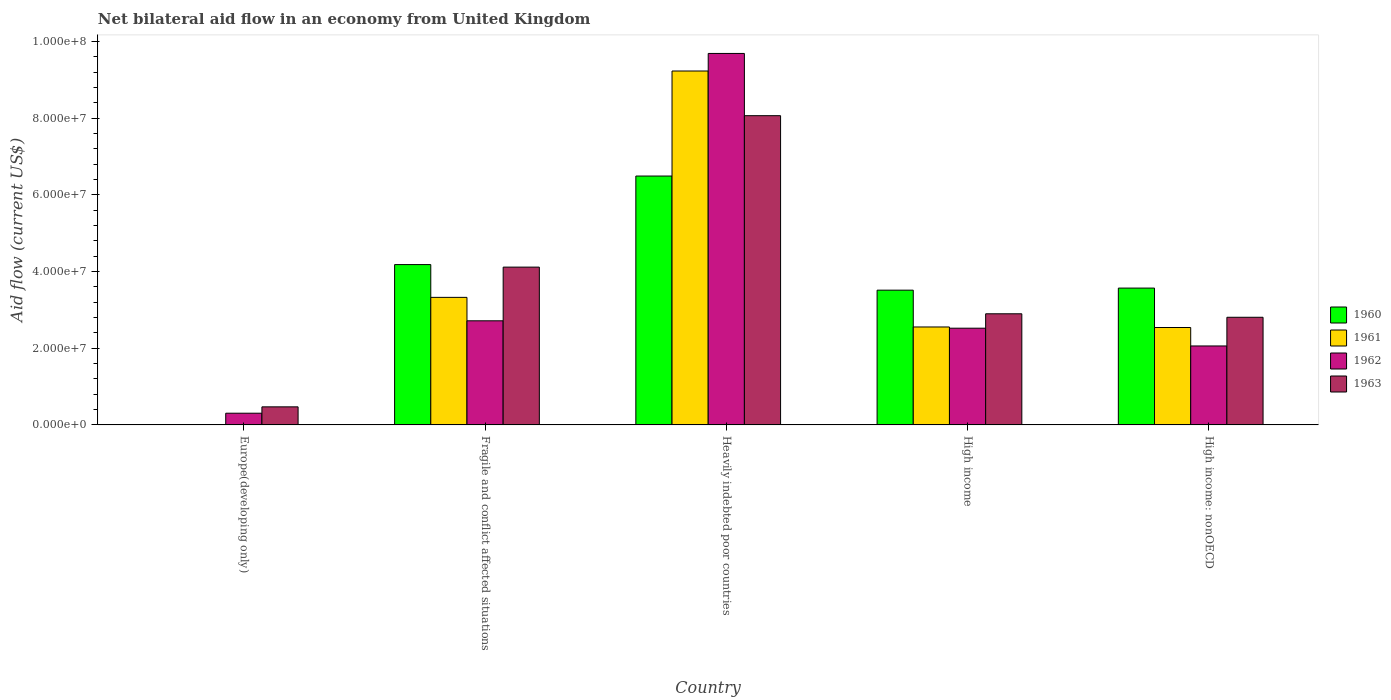How many different coloured bars are there?
Your response must be concise. 4. Are the number of bars per tick equal to the number of legend labels?
Provide a short and direct response. No. How many bars are there on the 1st tick from the left?
Give a very brief answer. 2. In how many cases, is the number of bars for a given country not equal to the number of legend labels?
Provide a succinct answer. 1. What is the net bilateral aid flow in 1960 in Heavily indebted poor countries?
Give a very brief answer. 6.49e+07. Across all countries, what is the maximum net bilateral aid flow in 1960?
Offer a terse response. 6.49e+07. Across all countries, what is the minimum net bilateral aid flow in 1961?
Provide a succinct answer. 0. In which country was the net bilateral aid flow in 1961 maximum?
Ensure brevity in your answer.  Heavily indebted poor countries. What is the total net bilateral aid flow in 1960 in the graph?
Offer a terse response. 1.78e+08. What is the difference between the net bilateral aid flow in 1962 in Europe(developing only) and that in Fragile and conflict affected situations?
Your answer should be compact. -2.41e+07. What is the difference between the net bilateral aid flow in 1963 in Heavily indebted poor countries and the net bilateral aid flow in 1960 in Fragile and conflict affected situations?
Provide a succinct answer. 3.88e+07. What is the average net bilateral aid flow in 1962 per country?
Provide a succinct answer. 3.46e+07. What is the difference between the net bilateral aid flow of/in 1962 and net bilateral aid flow of/in 1963 in Heavily indebted poor countries?
Offer a terse response. 1.62e+07. In how many countries, is the net bilateral aid flow in 1961 greater than 88000000 US$?
Provide a short and direct response. 1. What is the ratio of the net bilateral aid flow in 1961 in Fragile and conflict affected situations to that in Heavily indebted poor countries?
Your response must be concise. 0.36. Is the difference between the net bilateral aid flow in 1962 in Fragile and conflict affected situations and Heavily indebted poor countries greater than the difference between the net bilateral aid flow in 1963 in Fragile and conflict affected situations and Heavily indebted poor countries?
Your answer should be very brief. No. What is the difference between the highest and the second highest net bilateral aid flow in 1960?
Provide a succinct answer. 2.92e+07. What is the difference between the highest and the lowest net bilateral aid flow in 1960?
Make the answer very short. 6.49e+07. In how many countries, is the net bilateral aid flow in 1963 greater than the average net bilateral aid flow in 1963 taken over all countries?
Make the answer very short. 2. Is the sum of the net bilateral aid flow in 1960 in Fragile and conflict affected situations and High income: nonOECD greater than the maximum net bilateral aid flow in 1963 across all countries?
Your response must be concise. No. Is it the case that in every country, the sum of the net bilateral aid flow in 1962 and net bilateral aid flow in 1961 is greater than the sum of net bilateral aid flow in 1960 and net bilateral aid flow in 1963?
Your response must be concise. No. Does the graph contain any zero values?
Your answer should be compact. Yes. Does the graph contain grids?
Offer a terse response. No. How are the legend labels stacked?
Your response must be concise. Vertical. What is the title of the graph?
Keep it short and to the point. Net bilateral aid flow in an economy from United Kingdom. Does "1961" appear as one of the legend labels in the graph?
Ensure brevity in your answer.  Yes. What is the label or title of the X-axis?
Give a very brief answer. Country. What is the Aid flow (current US$) in 1960 in Europe(developing only)?
Your response must be concise. 0. What is the Aid flow (current US$) of 1961 in Europe(developing only)?
Your answer should be compact. 0. What is the Aid flow (current US$) of 1962 in Europe(developing only)?
Ensure brevity in your answer.  3.05e+06. What is the Aid flow (current US$) of 1963 in Europe(developing only)?
Your answer should be very brief. 4.71e+06. What is the Aid flow (current US$) of 1960 in Fragile and conflict affected situations?
Provide a short and direct response. 4.18e+07. What is the Aid flow (current US$) in 1961 in Fragile and conflict affected situations?
Ensure brevity in your answer.  3.33e+07. What is the Aid flow (current US$) in 1962 in Fragile and conflict affected situations?
Offer a very short reply. 2.72e+07. What is the Aid flow (current US$) of 1963 in Fragile and conflict affected situations?
Ensure brevity in your answer.  4.12e+07. What is the Aid flow (current US$) of 1960 in Heavily indebted poor countries?
Your response must be concise. 6.49e+07. What is the Aid flow (current US$) of 1961 in Heavily indebted poor countries?
Keep it short and to the point. 9.23e+07. What is the Aid flow (current US$) of 1962 in Heavily indebted poor countries?
Your answer should be compact. 9.69e+07. What is the Aid flow (current US$) of 1963 in Heavily indebted poor countries?
Your answer should be compact. 8.06e+07. What is the Aid flow (current US$) in 1960 in High income?
Offer a terse response. 3.51e+07. What is the Aid flow (current US$) in 1961 in High income?
Give a very brief answer. 2.55e+07. What is the Aid flow (current US$) in 1962 in High income?
Provide a short and direct response. 2.52e+07. What is the Aid flow (current US$) of 1963 in High income?
Keep it short and to the point. 2.90e+07. What is the Aid flow (current US$) in 1960 in High income: nonOECD?
Give a very brief answer. 3.57e+07. What is the Aid flow (current US$) of 1961 in High income: nonOECD?
Give a very brief answer. 2.54e+07. What is the Aid flow (current US$) in 1962 in High income: nonOECD?
Make the answer very short. 2.06e+07. What is the Aid flow (current US$) of 1963 in High income: nonOECD?
Ensure brevity in your answer.  2.81e+07. Across all countries, what is the maximum Aid flow (current US$) of 1960?
Ensure brevity in your answer.  6.49e+07. Across all countries, what is the maximum Aid flow (current US$) in 1961?
Make the answer very short. 9.23e+07. Across all countries, what is the maximum Aid flow (current US$) of 1962?
Give a very brief answer. 9.69e+07. Across all countries, what is the maximum Aid flow (current US$) of 1963?
Give a very brief answer. 8.06e+07. Across all countries, what is the minimum Aid flow (current US$) in 1962?
Provide a short and direct response. 3.05e+06. Across all countries, what is the minimum Aid flow (current US$) of 1963?
Offer a very short reply. 4.71e+06. What is the total Aid flow (current US$) of 1960 in the graph?
Provide a succinct answer. 1.78e+08. What is the total Aid flow (current US$) in 1961 in the graph?
Your response must be concise. 1.76e+08. What is the total Aid flow (current US$) of 1962 in the graph?
Ensure brevity in your answer.  1.73e+08. What is the total Aid flow (current US$) of 1963 in the graph?
Offer a terse response. 1.84e+08. What is the difference between the Aid flow (current US$) of 1962 in Europe(developing only) and that in Fragile and conflict affected situations?
Your answer should be compact. -2.41e+07. What is the difference between the Aid flow (current US$) in 1963 in Europe(developing only) and that in Fragile and conflict affected situations?
Offer a very short reply. -3.64e+07. What is the difference between the Aid flow (current US$) of 1962 in Europe(developing only) and that in Heavily indebted poor countries?
Offer a terse response. -9.38e+07. What is the difference between the Aid flow (current US$) of 1963 in Europe(developing only) and that in Heavily indebted poor countries?
Provide a short and direct response. -7.59e+07. What is the difference between the Aid flow (current US$) in 1962 in Europe(developing only) and that in High income?
Make the answer very short. -2.22e+07. What is the difference between the Aid flow (current US$) in 1963 in Europe(developing only) and that in High income?
Offer a terse response. -2.43e+07. What is the difference between the Aid flow (current US$) in 1962 in Europe(developing only) and that in High income: nonOECD?
Your answer should be compact. -1.75e+07. What is the difference between the Aid flow (current US$) of 1963 in Europe(developing only) and that in High income: nonOECD?
Keep it short and to the point. -2.34e+07. What is the difference between the Aid flow (current US$) of 1960 in Fragile and conflict affected situations and that in Heavily indebted poor countries?
Keep it short and to the point. -2.31e+07. What is the difference between the Aid flow (current US$) of 1961 in Fragile and conflict affected situations and that in Heavily indebted poor countries?
Provide a succinct answer. -5.90e+07. What is the difference between the Aid flow (current US$) of 1962 in Fragile and conflict affected situations and that in Heavily indebted poor countries?
Offer a terse response. -6.97e+07. What is the difference between the Aid flow (current US$) in 1963 in Fragile and conflict affected situations and that in Heavily indebted poor countries?
Your response must be concise. -3.95e+07. What is the difference between the Aid flow (current US$) in 1960 in Fragile and conflict affected situations and that in High income?
Give a very brief answer. 6.67e+06. What is the difference between the Aid flow (current US$) in 1961 in Fragile and conflict affected situations and that in High income?
Make the answer very short. 7.72e+06. What is the difference between the Aid flow (current US$) of 1962 in Fragile and conflict affected situations and that in High income?
Give a very brief answer. 1.93e+06. What is the difference between the Aid flow (current US$) of 1963 in Fragile and conflict affected situations and that in High income?
Provide a succinct answer. 1.22e+07. What is the difference between the Aid flow (current US$) in 1960 in Fragile and conflict affected situations and that in High income: nonOECD?
Ensure brevity in your answer.  6.13e+06. What is the difference between the Aid flow (current US$) in 1961 in Fragile and conflict affected situations and that in High income: nonOECD?
Keep it short and to the point. 7.86e+06. What is the difference between the Aid flow (current US$) in 1962 in Fragile and conflict affected situations and that in High income: nonOECD?
Make the answer very short. 6.56e+06. What is the difference between the Aid flow (current US$) of 1963 in Fragile and conflict affected situations and that in High income: nonOECD?
Your response must be concise. 1.31e+07. What is the difference between the Aid flow (current US$) in 1960 in Heavily indebted poor countries and that in High income?
Ensure brevity in your answer.  2.98e+07. What is the difference between the Aid flow (current US$) of 1961 in Heavily indebted poor countries and that in High income?
Keep it short and to the point. 6.68e+07. What is the difference between the Aid flow (current US$) of 1962 in Heavily indebted poor countries and that in High income?
Ensure brevity in your answer.  7.16e+07. What is the difference between the Aid flow (current US$) of 1963 in Heavily indebted poor countries and that in High income?
Your answer should be very brief. 5.17e+07. What is the difference between the Aid flow (current US$) in 1960 in Heavily indebted poor countries and that in High income: nonOECD?
Make the answer very short. 2.92e+07. What is the difference between the Aid flow (current US$) of 1961 in Heavily indebted poor countries and that in High income: nonOECD?
Provide a succinct answer. 6.69e+07. What is the difference between the Aid flow (current US$) in 1962 in Heavily indebted poor countries and that in High income: nonOECD?
Give a very brief answer. 7.63e+07. What is the difference between the Aid flow (current US$) in 1963 in Heavily indebted poor countries and that in High income: nonOECD?
Your response must be concise. 5.26e+07. What is the difference between the Aid flow (current US$) of 1960 in High income and that in High income: nonOECD?
Your answer should be very brief. -5.40e+05. What is the difference between the Aid flow (current US$) of 1961 in High income and that in High income: nonOECD?
Offer a terse response. 1.40e+05. What is the difference between the Aid flow (current US$) in 1962 in High income and that in High income: nonOECD?
Your response must be concise. 4.63e+06. What is the difference between the Aid flow (current US$) of 1963 in High income and that in High income: nonOECD?
Keep it short and to the point. 9.10e+05. What is the difference between the Aid flow (current US$) of 1962 in Europe(developing only) and the Aid flow (current US$) of 1963 in Fragile and conflict affected situations?
Give a very brief answer. -3.81e+07. What is the difference between the Aid flow (current US$) in 1962 in Europe(developing only) and the Aid flow (current US$) in 1963 in Heavily indebted poor countries?
Your answer should be compact. -7.76e+07. What is the difference between the Aid flow (current US$) in 1962 in Europe(developing only) and the Aid flow (current US$) in 1963 in High income?
Provide a short and direct response. -2.59e+07. What is the difference between the Aid flow (current US$) in 1962 in Europe(developing only) and the Aid flow (current US$) in 1963 in High income: nonOECD?
Your answer should be compact. -2.50e+07. What is the difference between the Aid flow (current US$) in 1960 in Fragile and conflict affected situations and the Aid flow (current US$) in 1961 in Heavily indebted poor countries?
Your answer should be very brief. -5.05e+07. What is the difference between the Aid flow (current US$) of 1960 in Fragile and conflict affected situations and the Aid flow (current US$) of 1962 in Heavily indebted poor countries?
Offer a very short reply. -5.51e+07. What is the difference between the Aid flow (current US$) of 1960 in Fragile and conflict affected situations and the Aid flow (current US$) of 1963 in Heavily indebted poor countries?
Offer a very short reply. -3.88e+07. What is the difference between the Aid flow (current US$) of 1961 in Fragile and conflict affected situations and the Aid flow (current US$) of 1962 in Heavily indebted poor countries?
Offer a terse response. -6.36e+07. What is the difference between the Aid flow (current US$) of 1961 in Fragile and conflict affected situations and the Aid flow (current US$) of 1963 in Heavily indebted poor countries?
Make the answer very short. -4.74e+07. What is the difference between the Aid flow (current US$) of 1962 in Fragile and conflict affected situations and the Aid flow (current US$) of 1963 in Heavily indebted poor countries?
Your response must be concise. -5.35e+07. What is the difference between the Aid flow (current US$) in 1960 in Fragile and conflict affected situations and the Aid flow (current US$) in 1961 in High income?
Offer a very short reply. 1.63e+07. What is the difference between the Aid flow (current US$) of 1960 in Fragile and conflict affected situations and the Aid flow (current US$) of 1962 in High income?
Offer a terse response. 1.66e+07. What is the difference between the Aid flow (current US$) in 1960 in Fragile and conflict affected situations and the Aid flow (current US$) in 1963 in High income?
Your answer should be very brief. 1.28e+07. What is the difference between the Aid flow (current US$) in 1961 in Fragile and conflict affected situations and the Aid flow (current US$) in 1962 in High income?
Provide a short and direct response. 8.04e+06. What is the difference between the Aid flow (current US$) of 1961 in Fragile and conflict affected situations and the Aid flow (current US$) of 1963 in High income?
Keep it short and to the point. 4.28e+06. What is the difference between the Aid flow (current US$) in 1962 in Fragile and conflict affected situations and the Aid flow (current US$) in 1963 in High income?
Ensure brevity in your answer.  -1.83e+06. What is the difference between the Aid flow (current US$) of 1960 in Fragile and conflict affected situations and the Aid flow (current US$) of 1961 in High income: nonOECD?
Keep it short and to the point. 1.64e+07. What is the difference between the Aid flow (current US$) in 1960 in Fragile and conflict affected situations and the Aid flow (current US$) in 1962 in High income: nonOECD?
Keep it short and to the point. 2.12e+07. What is the difference between the Aid flow (current US$) of 1960 in Fragile and conflict affected situations and the Aid flow (current US$) of 1963 in High income: nonOECD?
Your response must be concise. 1.37e+07. What is the difference between the Aid flow (current US$) in 1961 in Fragile and conflict affected situations and the Aid flow (current US$) in 1962 in High income: nonOECD?
Provide a short and direct response. 1.27e+07. What is the difference between the Aid flow (current US$) in 1961 in Fragile and conflict affected situations and the Aid flow (current US$) in 1963 in High income: nonOECD?
Give a very brief answer. 5.19e+06. What is the difference between the Aid flow (current US$) of 1962 in Fragile and conflict affected situations and the Aid flow (current US$) of 1963 in High income: nonOECD?
Your answer should be compact. -9.20e+05. What is the difference between the Aid flow (current US$) in 1960 in Heavily indebted poor countries and the Aid flow (current US$) in 1961 in High income?
Make the answer very short. 3.94e+07. What is the difference between the Aid flow (current US$) of 1960 in Heavily indebted poor countries and the Aid flow (current US$) of 1962 in High income?
Give a very brief answer. 3.97e+07. What is the difference between the Aid flow (current US$) of 1960 in Heavily indebted poor countries and the Aid flow (current US$) of 1963 in High income?
Make the answer very short. 3.59e+07. What is the difference between the Aid flow (current US$) in 1961 in Heavily indebted poor countries and the Aid flow (current US$) in 1962 in High income?
Ensure brevity in your answer.  6.71e+07. What is the difference between the Aid flow (current US$) in 1961 in Heavily indebted poor countries and the Aid flow (current US$) in 1963 in High income?
Make the answer very short. 6.33e+07. What is the difference between the Aid flow (current US$) of 1962 in Heavily indebted poor countries and the Aid flow (current US$) of 1963 in High income?
Provide a short and direct response. 6.79e+07. What is the difference between the Aid flow (current US$) of 1960 in Heavily indebted poor countries and the Aid flow (current US$) of 1961 in High income: nonOECD?
Ensure brevity in your answer.  3.95e+07. What is the difference between the Aid flow (current US$) of 1960 in Heavily indebted poor countries and the Aid flow (current US$) of 1962 in High income: nonOECD?
Offer a very short reply. 4.43e+07. What is the difference between the Aid flow (current US$) of 1960 in Heavily indebted poor countries and the Aid flow (current US$) of 1963 in High income: nonOECD?
Make the answer very short. 3.68e+07. What is the difference between the Aid flow (current US$) of 1961 in Heavily indebted poor countries and the Aid flow (current US$) of 1962 in High income: nonOECD?
Your answer should be compact. 7.17e+07. What is the difference between the Aid flow (current US$) in 1961 in Heavily indebted poor countries and the Aid flow (current US$) in 1963 in High income: nonOECD?
Your answer should be compact. 6.42e+07. What is the difference between the Aid flow (current US$) in 1962 in Heavily indebted poor countries and the Aid flow (current US$) in 1963 in High income: nonOECD?
Your answer should be very brief. 6.88e+07. What is the difference between the Aid flow (current US$) of 1960 in High income and the Aid flow (current US$) of 1961 in High income: nonOECD?
Keep it short and to the point. 9.74e+06. What is the difference between the Aid flow (current US$) in 1960 in High income and the Aid flow (current US$) in 1962 in High income: nonOECD?
Your answer should be compact. 1.46e+07. What is the difference between the Aid flow (current US$) in 1960 in High income and the Aid flow (current US$) in 1963 in High income: nonOECD?
Your answer should be very brief. 7.07e+06. What is the difference between the Aid flow (current US$) of 1961 in High income and the Aid flow (current US$) of 1962 in High income: nonOECD?
Give a very brief answer. 4.95e+06. What is the difference between the Aid flow (current US$) in 1961 in High income and the Aid flow (current US$) in 1963 in High income: nonOECD?
Offer a very short reply. -2.53e+06. What is the difference between the Aid flow (current US$) in 1962 in High income and the Aid flow (current US$) in 1963 in High income: nonOECD?
Give a very brief answer. -2.85e+06. What is the average Aid flow (current US$) in 1960 per country?
Ensure brevity in your answer.  3.55e+07. What is the average Aid flow (current US$) of 1961 per country?
Offer a terse response. 3.53e+07. What is the average Aid flow (current US$) in 1962 per country?
Your response must be concise. 3.46e+07. What is the average Aid flow (current US$) in 1963 per country?
Your response must be concise. 3.67e+07. What is the difference between the Aid flow (current US$) of 1962 and Aid flow (current US$) of 1963 in Europe(developing only)?
Ensure brevity in your answer.  -1.66e+06. What is the difference between the Aid flow (current US$) of 1960 and Aid flow (current US$) of 1961 in Fragile and conflict affected situations?
Keep it short and to the point. 8.55e+06. What is the difference between the Aid flow (current US$) of 1960 and Aid flow (current US$) of 1962 in Fragile and conflict affected situations?
Your response must be concise. 1.47e+07. What is the difference between the Aid flow (current US$) in 1960 and Aid flow (current US$) in 1963 in Fragile and conflict affected situations?
Offer a terse response. 6.60e+05. What is the difference between the Aid flow (current US$) in 1961 and Aid flow (current US$) in 1962 in Fragile and conflict affected situations?
Ensure brevity in your answer.  6.11e+06. What is the difference between the Aid flow (current US$) in 1961 and Aid flow (current US$) in 1963 in Fragile and conflict affected situations?
Your answer should be very brief. -7.89e+06. What is the difference between the Aid flow (current US$) of 1962 and Aid flow (current US$) of 1963 in Fragile and conflict affected situations?
Provide a succinct answer. -1.40e+07. What is the difference between the Aid flow (current US$) in 1960 and Aid flow (current US$) in 1961 in Heavily indebted poor countries?
Your answer should be compact. -2.74e+07. What is the difference between the Aid flow (current US$) of 1960 and Aid flow (current US$) of 1962 in Heavily indebted poor countries?
Your answer should be compact. -3.20e+07. What is the difference between the Aid flow (current US$) of 1960 and Aid flow (current US$) of 1963 in Heavily indebted poor countries?
Give a very brief answer. -1.57e+07. What is the difference between the Aid flow (current US$) of 1961 and Aid flow (current US$) of 1962 in Heavily indebted poor countries?
Offer a very short reply. -4.58e+06. What is the difference between the Aid flow (current US$) in 1961 and Aid flow (current US$) in 1963 in Heavily indebted poor countries?
Your response must be concise. 1.16e+07. What is the difference between the Aid flow (current US$) of 1962 and Aid flow (current US$) of 1963 in Heavily indebted poor countries?
Offer a terse response. 1.62e+07. What is the difference between the Aid flow (current US$) in 1960 and Aid flow (current US$) in 1961 in High income?
Give a very brief answer. 9.60e+06. What is the difference between the Aid flow (current US$) of 1960 and Aid flow (current US$) of 1962 in High income?
Your response must be concise. 9.92e+06. What is the difference between the Aid flow (current US$) in 1960 and Aid flow (current US$) in 1963 in High income?
Provide a succinct answer. 6.16e+06. What is the difference between the Aid flow (current US$) of 1961 and Aid flow (current US$) of 1963 in High income?
Give a very brief answer. -3.44e+06. What is the difference between the Aid flow (current US$) of 1962 and Aid flow (current US$) of 1963 in High income?
Make the answer very short. -3.76e+06. What is the difference between the Aid flow (current US$) in 1960 and Aid flow (current US$) in 1961 in High income: nonOECD?
Ensure brevity in your answer.  1.03e+07. What is the difference between the Aid flow (current US$) in 1960 and Aid flow (current US$) in 1962 in High income: nonOECD?
Ensure brevity in your answer.  1.51e+07. What is the difference between the Aid flow (current US$) in 1960 and Aid flow (current US$) in 1963 in High income: nonOECD?
Give a very brief answer. 7.61e+06. What is the difference between the Aid flow (current US$) of 1961 and Aid flow (current US$) of 1962 in High income: nonOECD?
Offer a very short reply. 4.81e+06. What is the difference between the Aid flow (current US$) in 1961 and Aid flow (current US$) in 1963 in High income: nonOECD?
Offer a terse response. -2.67e+06. What is the difference between the Aid flow (current US$) in 1962 and Aid flow (current US$) in 1963 in High income: nonOECD?
Make the answer very short. -7.48e+06. What is the ratio of the Aid flow (current US$) of 1962 in Europe(developing only) to that in Fragile and conflict affected situations?
Give a very brief answer. 0.11. What is the ratio of the Aid flow (current US$) in 1963 in Europe(developing only) to that in Fragile and conflict affected situations?
Offer a terse response. 0.11. What is the ratio of the Aid flow (current US$) of 1962 in Europe(developing only) to that in Heavily indebted poor countries?
Keep it short and to the point. 0.03. What is the ratio of the Aid flow (current US$) of 1963 in Europe(developing only) to that in Heavily indebted poor countries?
Your answer should be compact. 0.06. What is the ratio of the Aid flow (current US$) in 1962 in Europe(developing only) to that in High income?
Your response must be concise. 0.12. What is the ratio of the Aid flow (current US$) of 1963 in Europe(developing only) to that in High income?
Provide a short and direct response. 0.16. What is the ratio of the Aid flow (current US$) in 1962 in Europe(developing only) to that in High income: nonOECD?
Make the answer very short. 0.15. What is the ratio of the Aid flow (current US$) of 1963 in Europe(developing only) to that in High income: nonOECD?
Ensure brevity in your answer.  0.17. What is the ratio of the Aid flow (current US$) in 1960 in Fragile and conflict affected situations to that in Heavily indebted poor countries?
Ensure brevity in your answer.  0.64. What is the ratio of the Aid flow (current US$) of 1961 in Fragile and conflict affected situations to that in Heavily indebted poor countries?
Your response must be concise. 0.36. What is the ratio of the Aid flow (current US$) in 1962 in Fragile and conflict affected situations to that in Heavily indebted poor countries?
Keep it short and to the point. 0.28. What is the ratio of the Aid flow (current US$) of 1963 in Fragile and conflict affected situations to that in Heavily indebted poor countries?
Give a very brief answer. 0.51. What is the ratio of the Aid flow (current US$) in 1960 in Fragile and conflict affected situations to that in High income?
Ensure brevity in your answer.  1.19. What is the ratio of the Aid flow (current US$) in 1961 in Fragile and conflict affected situations to that in High income?
Offer a very short reply. 1.3. What is the ratio of the Aid flow (current US$) of 1962 in Fragile and conflict affected situations to that in High income?
Give a very brief answer. 1.08. What is the ratio of the Aid flow (current US$) of 1963 in Fragile and conflict affected situations to that in High income?
Offer a very short reply. 1.42. What is the ratio of the Aid flow (current US$) of 1960 in Fragile and conflict affected situations to that in High income: nonOECD?
Provide a short and direct response. 1.17. What is the ratio of the Aid flow (current US$) in 1961 in Fragile and conflict affected situations to that in High income: nonOECD?
Your answer should be very brief. 1.31. What is the ratio of the Aid flow (current US$) of 1962 in Fragile and conflict affected situations to that in High income: nonOECD?
Offer a very short reply. 1.32. What is the ratio of the Aid flow (current US$) of 1963 in Fragile and conflict affected situations to that in High income: nonOECD?
Ensure brevity in your answer.  1.47. What is the ratio of the Aid flow (current US$) in 1960 in Heavily indebted poor countries to that in High income?
Provide a short and direct response. 1.85. What is the ratio of the Aid flow (current US$) in 1961 in Heavily indebted poor countries to that in High income?
Provide a succinct answer. 3.61. What is the ratio of the Aid flow (current US$) of 1962 in Heavily indebted poor countries to that in High income?
Ensure brevity in your answer.  3.84. What is the ratio of the Aid flow (current US$) of 1963 in Heavily indebted poor countries to that in High income?
Make the answer very short. 2.78. What is the ratio of the Aid flow (current US$) of 1960 in Heavily indebted poor countries to that in High income: nonOECD?
Provide a succinct answer. 1.82. What is the ratio of the Aid flow (current US$) of 1961 in Heavily indebted poor countries to that in High income: nonOECD?
Provide a succinct answer. 3.63. What is the ratio of the Aid flow (current US$) of 1962 in Heavily indebted poor countries to that in High income: nonOECD?
Provide a short and direct response. 4.7. What is the ratio of the Aid flow (current US$) of 1963 in Heavily indebted poor countries to that in High income: nonOECD?
Offer a terse response. 2.87. What is the ratio of the Aid flow (current US$) in 1960 in High income to that in High income: nonOECD?
Your response must be concise. 0.98. What is the ratio of the Aid flow (current US$) in 1961 in High income to that in High income: nonOECD?
Offer a terse response. 1.01. What is the ratio of the Aid flow (current US$) of 1962 in High income to that in High income: nonOECD?
Give a very brief answer. 1.22. What is the ratio of the Aid flow (current US$) of 1963 in High income to that in High income: nonOECD?
Ensure brevity in your answer.  1.03. What is the difference between the highest and the second highest Aid flow (current US$) in 1960?
Make the answer very short. 2.31e+07. What is the difference between the highest and the second highest Aid flow (current US$) of 1961?
Offer a very short reply. 5.90e+07. What is the difference between the highest and the second highest Aid flow (current US$) in 1962?
Provide a succinct answer. 6.97e+07. What is the difference between the highest and the second highest Aid flow (current US$) in 1963?
Your answer should be very brief. 3.95e+07. What is the difference between the highest and the lowest Aid flow (current US$) in 1960?
Your answer should be very brief. 6.49e+07. What is the difference between the highest and the lowest Aid flow (current US$) of 1961?
Keep it short and to the point. 9.23e+07. What is the difference between the highest and the lowest Aid flow (current US$) of 1962?
Ensure brevity in your answer.  9.38e+07. What is the difference between the highest and the lowest Aid flow (current US$) in 1963?
Offer a terse response. 7.59e+07. 